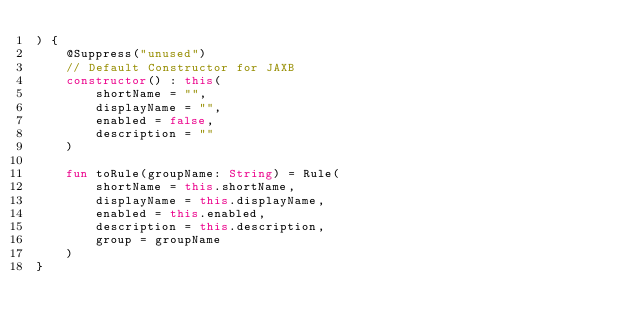<code> <loc_0><loc_0><loc_500><loc_500><_Kotlin_>) {
    @Suppress("unused")
    // Default Constructor for JAXB
    constructor() : this(
        shortName = "",
        displayName = "",
        enabled = false,
        description = ""
    )

    fun toRule(groupName: String) = Rule(
        shortName = this.shortName,
        displayName = this.displayName,
        enabled = this.enabled,
        description = this.description,
        group = groupName
    )
}
</code> 